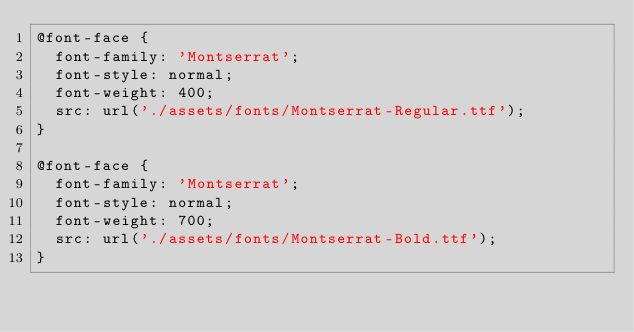<code> <loc_0><loc_0><loc_500><loc_500><_CSS_>@font-face {
  font-family: 'Montserrat';
  font-style: normal;
  font-weight: 400;
  src: url('./assets/fonts/Montserrat-Regular.ttf');
}

@font-face {
  font-family: 'Montserrat';
  font-style: normal;
  font-weight: 700;
  src: url('./assets/fonts/Montserrat-Bold.ttf');
}
</code> 